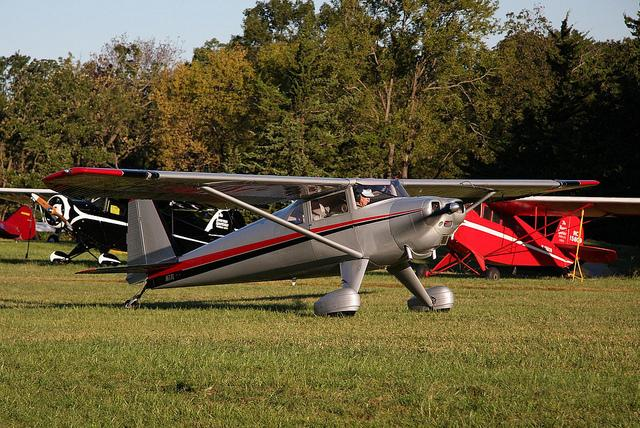What powers this plane? engine 